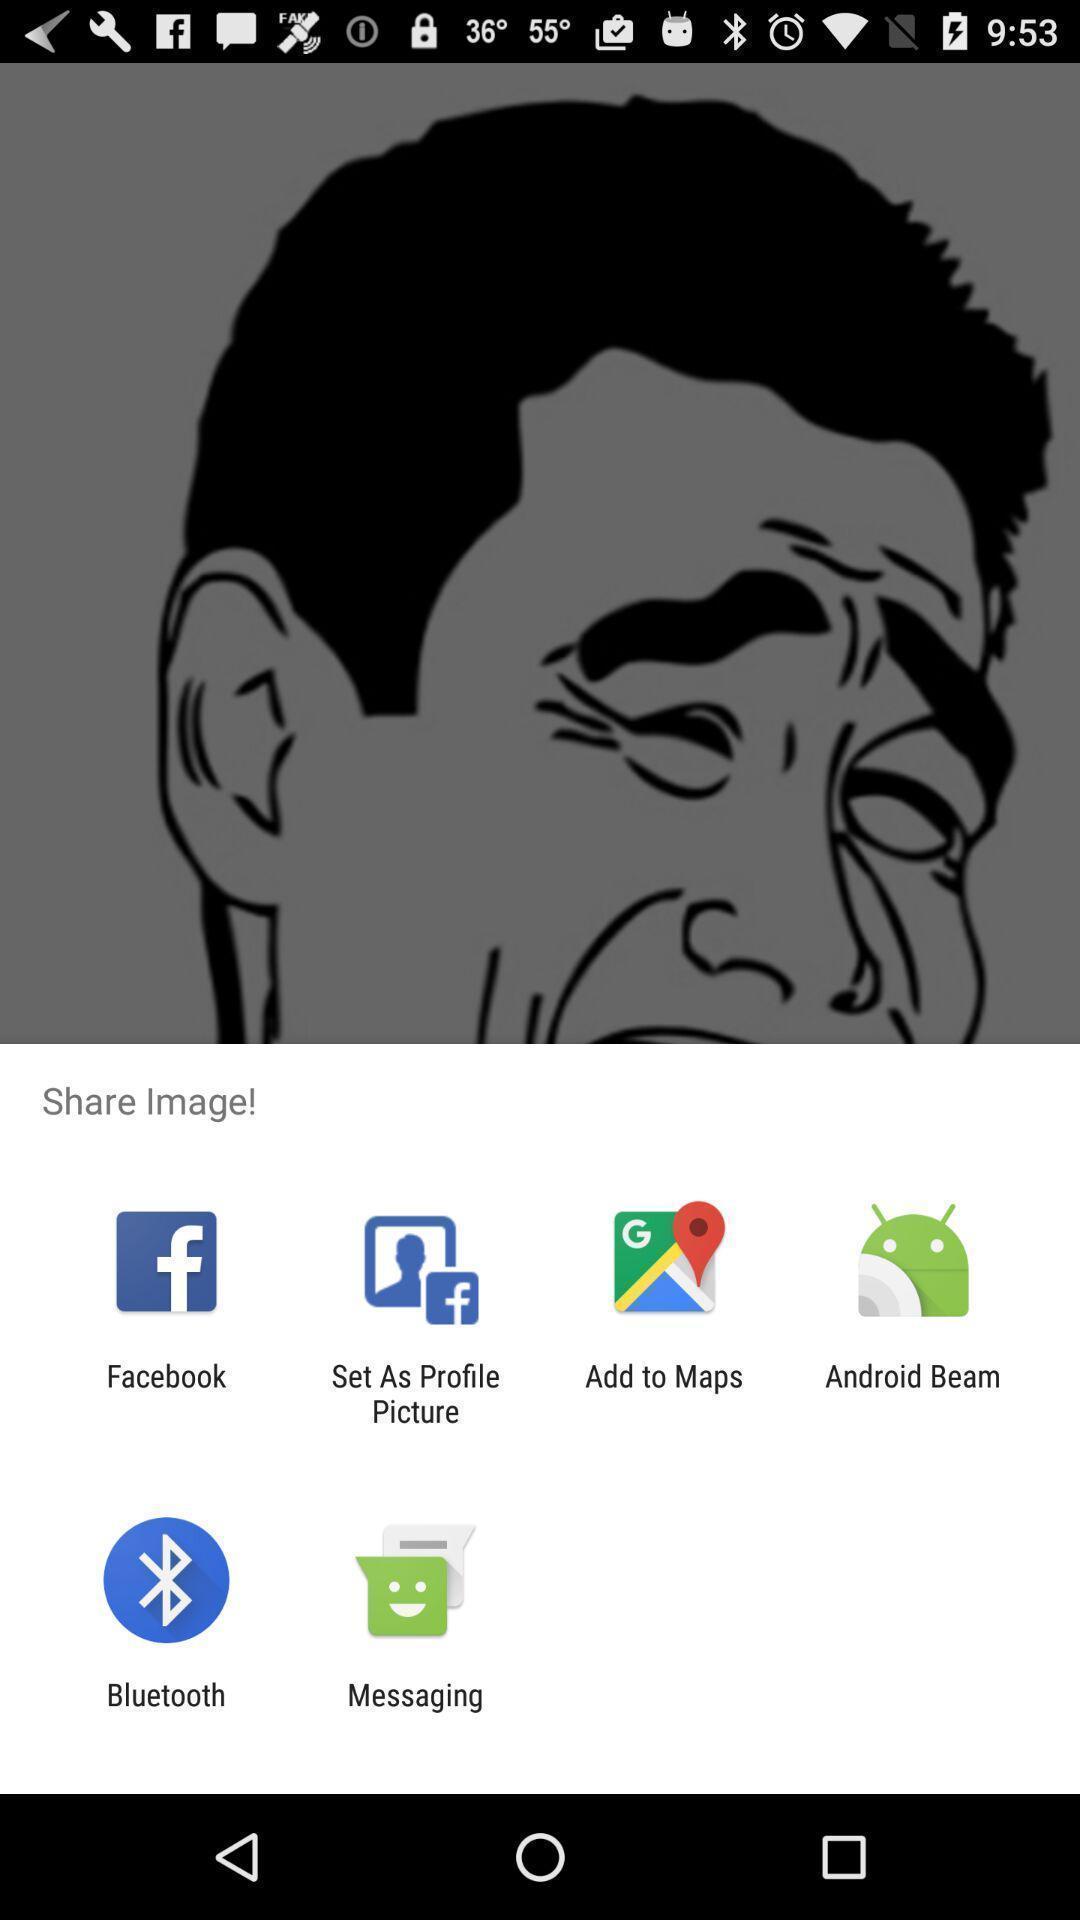Explain the elements present in this screenshot. Pop-up showing various options to share an image. 